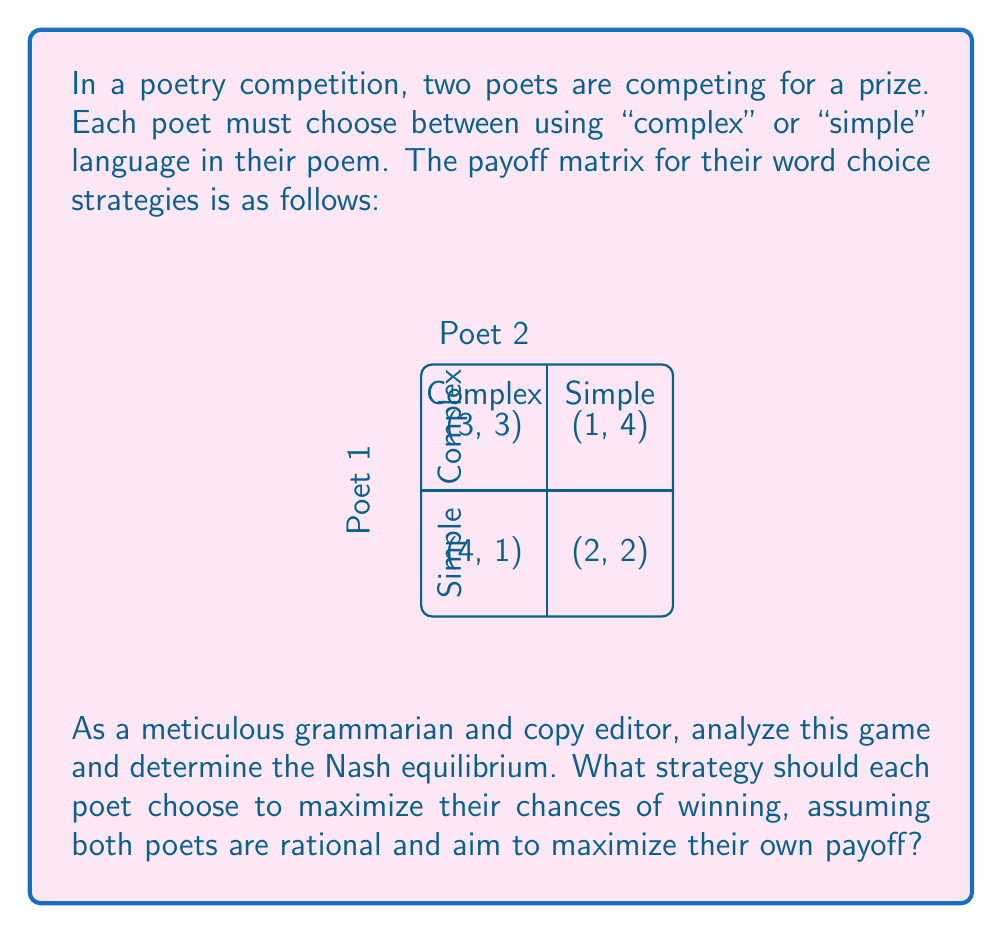Teach me how to tackle this problem. To find the Nash equilibrium, we need to analyze each poet's best response to the other's strategy:

1. For Poet 1:
   - If Poet 2 chooses Complex, Poet 1's best response is Complex (3 > 1)
   - If Poet 2 chooses Simple, Poet 1's best response is Complex (4 > 2)

2. For Poet 2:
   - If Poet 1 chooses Complex, Poet 2's best response is Complex (3 > 1)
   - If Poet 1 chooses Simple, Poet 2's best response is Simple (4 > 2)

3. Nash equilibrium occurs when both poets choose their best response to the other's strategy simultaneously.

4. From the analysis, we can see that (Complex, Complex) is a Nash equilibrium because neither poet can unilaterally improve their payoff by changing their strategy.

5. To verify, let's check if there are any other Nash equilibria:
   - (Complex, Simple) is not an equilibrium because Poet 2 can improve by switching to Complex
   - (Simple, Complex) is not an equilibrium because Poet 1 can improve by switching to Complex
   - (Simple, Simple) is not an equilibrium because both poets can improve by switching to Complex

6. Therefore, the unique Nash equilibrium is (Complex, Complex) with a payoff of (3, 3).

From a grammarian's perspective, this equilibrium suggests that in a competitive setting, poets may tend towards more complex language to maximize their chances of winning, even if this might not always result in the most accessible or effective poetry for readers.
Answer: (Complex, Complex) 